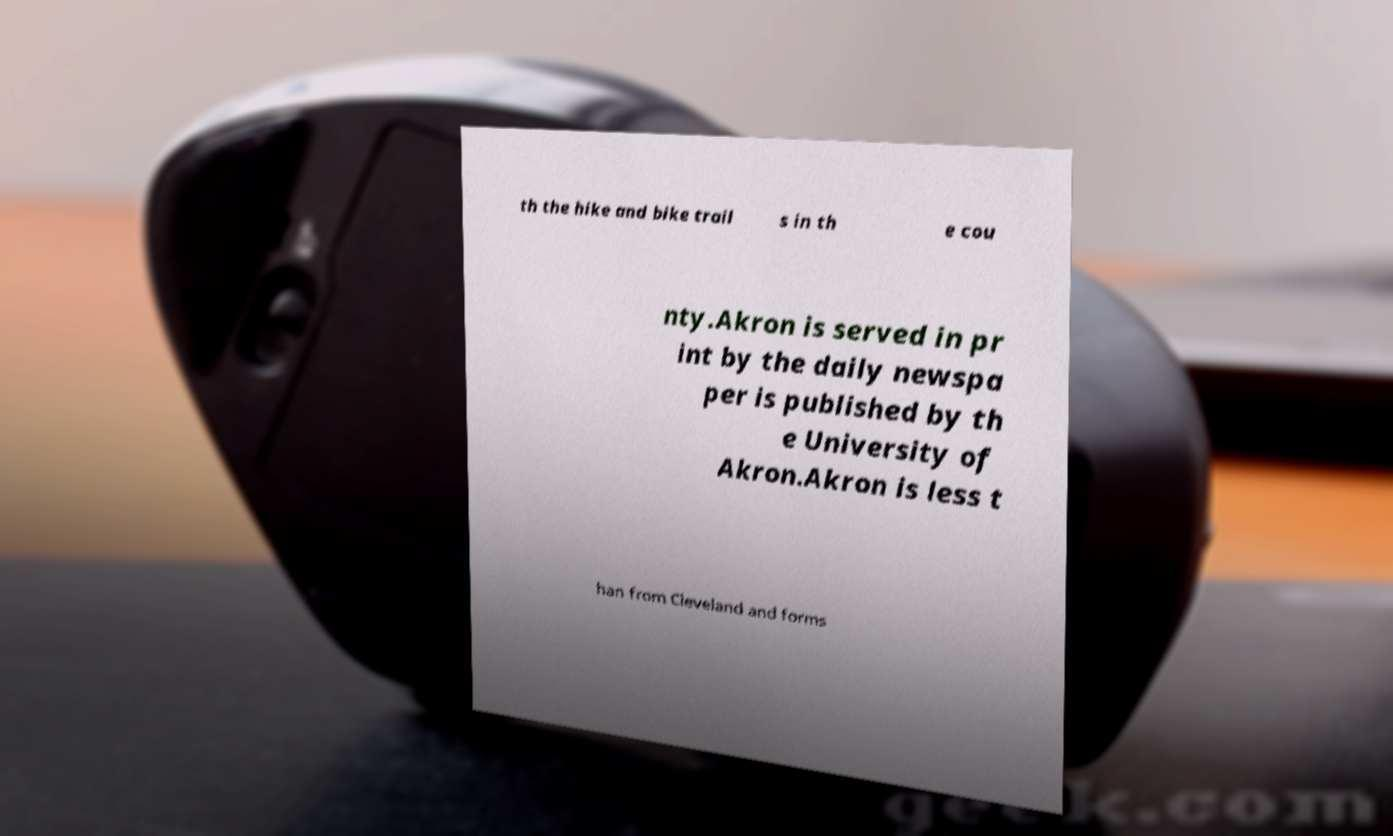Can you accurately transcribe the text from the provided image for me? th the hike and bike trail s in th e cou nty.Akron is served in pr int by the daily newspa per is published by th e University of Akron.Akron is less t han from Cleveland and forms 